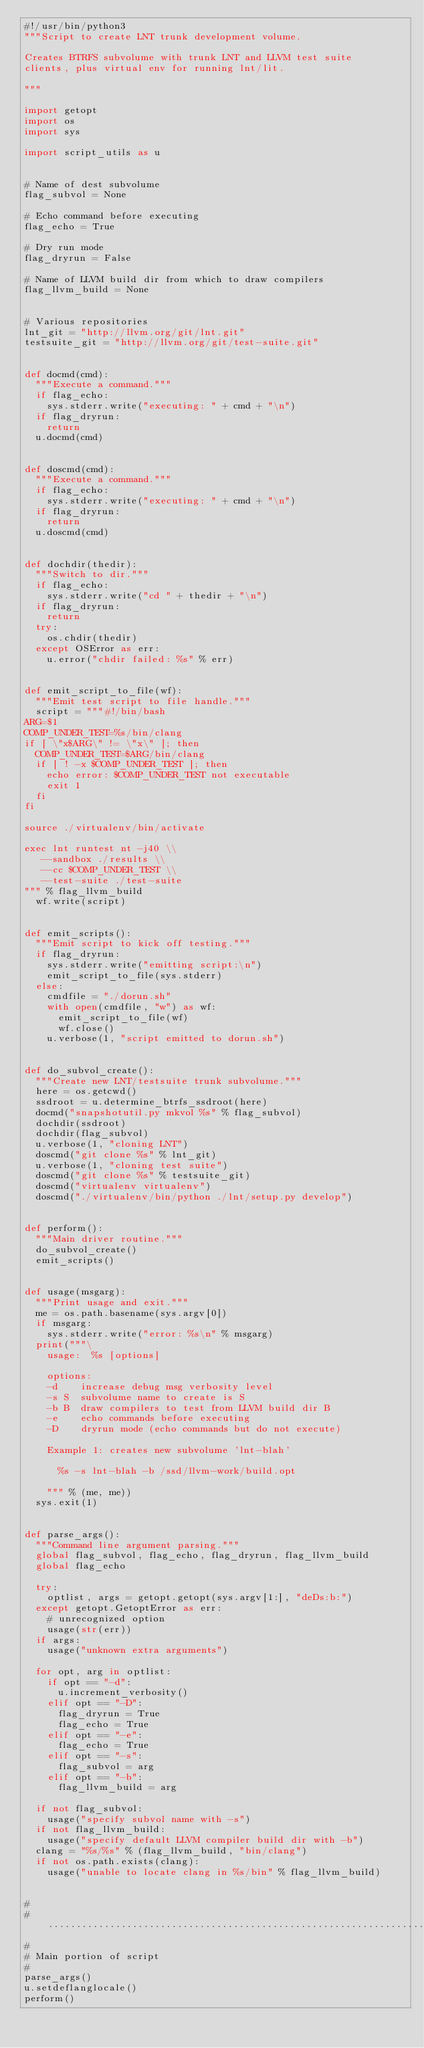<code> <loc_0><loc_0><loc_500><loc_500><_Python_>#!/usr/bin/python3
"""Script to create LNT trunk development volume.

Creates BTRFS subvolume with trunk LNT and LLVM test suite
clients, plus virtual env for running lnt/lit.

"""

import getopt
import os
import sys

import script_utils as u


# Name of dest subvolume
flag_subvol = None

# Echo command before executing
flag_echo = True

# Dry run mode
flag_dryrun = False

# Name of LLVM build dir from which to draw compilers
flag_llvm_build = None


# Various repositories
lnt_git = "http://llvm.org/git/lnt.git"
testsuite_git = "http://llvm.org/git/test-suite.git"


def docmd(cmd):
  """Execute a command."""
  if flag_echo:
    sys.stderr.write("executing: " + cmd + "\n")
  if flag_dryrun:
    return
  u.docmd(cmd)


def doscmd(cmd):
  """Execute a command."""
  if flag_echo:
    sys.stderr.write("executing: " + cmd + "\n")
  if flag_dryrun:
    return
  u.doscmd(cmd)


def dochdir(thedir):
  """Switch to dir."""
  if flag_echo:
    sys.stderr.write("cd " + thedir + "\n")
  if flag_dryrun:
    return
  try:
    os.chdir(thedir)
  except OSError as err:
    u.error("chdir failed: %s" % err)


def emit_script_to_file(wf):
  """Emit test script to file handle."""
  script = """#!/bin/bash
ARG=$1
COMP_UNDER_TEST=%s/bin/clang
if [ \"x$ARG\" != \"x\" ]; then
  COMP_UNDER_TEST=$ARG/bin/clang
  if [ ! -x $COMP_UNDER_TEST ]; then
    echo error: $COMP_UNDER_TEST not executable
    exit 1
  fi
fi

source ./virtualenv/bin/activate

exec lnt runtest nt -j40 \\
   --sandbox ./results \\
   --cc $COMP_UNDER_TEST \\
   --test-suite ./test-suite
""" % flag_llvm_build
  wf.write(script)


def emit_scripts():
  """Emit script to kick off testing."""
  if flag_dryrun:
    sys.stderr.write("emitting script:\n")
    emit_script_to_file(sys.stderr)
  else:
    cmdfile = "./dorun.sh"
    with open(cmdfile, "w") as wf:
      emit_script_to_file(wf)
      wf.close()
    u.verbose(1, "script emitted to dorun.sh")


def do_subvol_create():
  """Create new LNT/testsuite trunk subvolume."""
  here = os.getcwd()
  ssdroot = u.determine_btrfs_ssdroot(here)
  docmd("snapshotutil.py mkvol %s" % flag_subvol)
  dochdir(ssdroot)
  dochdir(flag_subvol)
  u.verbose(1, "cloning LNT")
  doscmd("git clone %s" % lnt_git)
  u.verbose(1, "cloning test suite")
  doscmd("git clone %s" % testsuite_git)
  doscmd("virtualenv virtualenv")
  doscmd("./virtualenv/bin/python ./lnt/setup.py develop")


def perform():
  """Main driver routine."""
  do_subvol_create()
  emit_scripts()


def usage(msgarg):
  """Print usage and exit."""
  me = os.path.basename(sys.argv[0])
  if msgarg:
    sys.stderr.write("error: %s\n" % msgarg)
  print("""\
    usage:  %s [options]

    options:
    -d    increase debug msg verbosity level
    -s S  subvolume name to create is S
    -b B  draw compilers to test from LLVM build dir B
    -e    echo commands before executing
    -D    dryrun mode (echo commands but do not execute)

    Example 1: creates new subvolume 'lnt-blah'

      %s -s lnt-blah -b /ssd/llvm-work/build.opt

    """ % (me, me))
  sys.exit(1)


def parse_args():
  """Command line argument parsing."""
  global flag_subvol, flag_echo, flag_dryrun, flag_llvm_build
  global flag_echo

  try:
    optlist, args = getopt.getopt(sys.argv[1:], "deDs:b:")
  except getopt.GetoptError as err:
    # unrecognized option
    usage(str(err))
  if args:
    usage("unknown extra arguments")

  for opt, arg in optlist:
    if opt == "-d":
      u.increment_verbosity()
    elif opt == "-D":
      flag_dryrun = True
      flag_echo = True
    elif opt == "-e":
      flag_echo = True
    elif opt == "-s":
      flag_subvol = arg
    elif opt == "-b":
      flag_llvm_build = arg

  if not flag_subvol:
    usage("specify subvol name with -s")
  if not flag_llvm_build:
    usage("specify default LLVM compiler build dir with -b")
  clang = "%s/%s" % (flag_llvm_build, "bin/clang")
  if not os.path.exists(clang):
    usage("unable to locate clang in %s/bin" % flag_llvm_build)


#
#......................................................................
#
# Main portion of script
#
parse_args()
u.setdeflanglocale()
perform()
</code> 